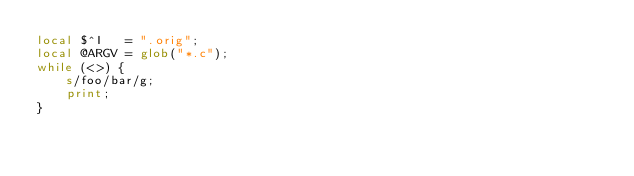Convert code to text. <code><loc_0><loc_0><loc_500><loc_500><_Perl_>local $^I   = ".orig";
local @ARGV = glob("*.c");
while (<>) {
    s/foo/bar/g;
    print;
}
</code> 